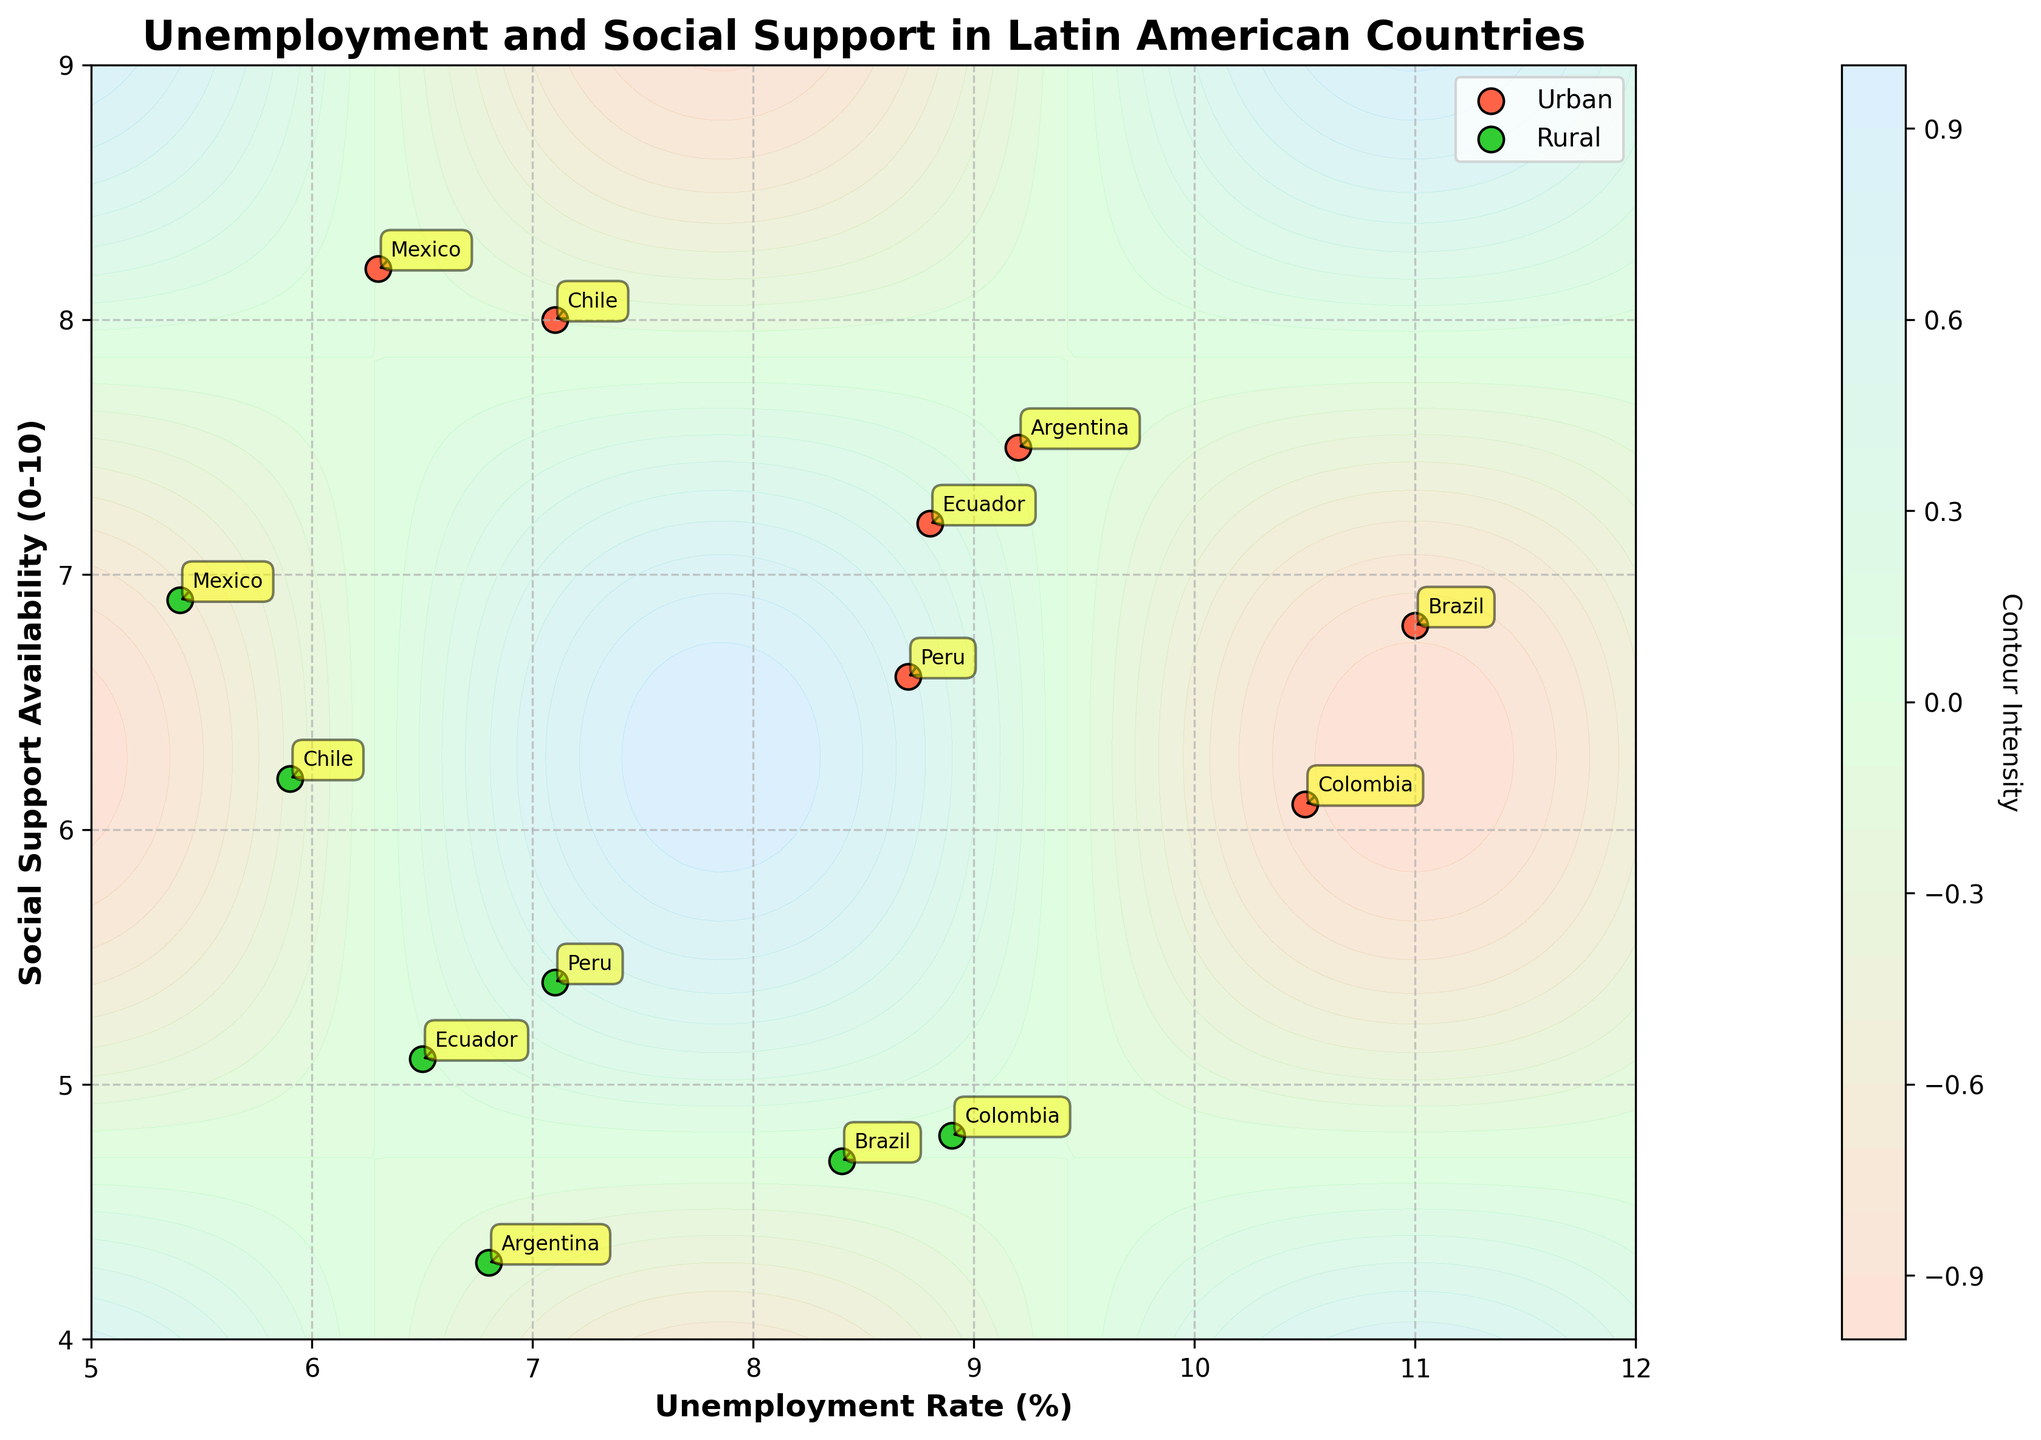What's the title of the figure? The title of the figure is located at the top center of the plot. It reads "Unemployment and Social Support in Latin American Countries".
Answer: Unemployment and Social Support in Latin American Countries What is the unemployment rate for rural areas in Mexico? To find the unemployment rate for rural areas in Mexico, look at the scatter point labeled "Mexico" within the green dots. The unemployment rate is marked on the horizontal axis.
Answer: 5.4% Which country has the highest social support availability in rural areas? Look at the scatter points in green (which represent rural areas). Identify the point with the highest value on the vertical axis marked "Social Support Availability (0-10)". The highest point corresponds to Mexico.
Answer: Mexico What is the difference in unemployment rate between urban and rural areas in Argentina? Identify the points labeled "Argentina" in both the red and green categories. The unemployment rate for urban areas is 9.2%, and for rural areas, it is 6.8%. Subtract the rural rate from the urban rate: 9.2% - 6.8% = 2.4%.
Answer: 2.4% What is the average social support availability for urban areas in Brazil, Argentina, and Chile? To find this, locate the points for urban areas in Brazil, Argentina, and Chile (red scatter points). The social support availabilities are 6.8 for Brazil, 7.5 for Argentina, and 8.0 for Chile. Calculate: (6.8 + 7.5 + 8.0) / 3 = 7.43.
Answer: 7.43 Between Chile and Colombia, which country has a higher unemployment rate in rural areas? Look at the green scatter points labeled "Chile" and "Colombia". The unemployment rate for rural Chile is 5.9%, and for rural Colombia, it is 8.9%. Colombia has a higher rate.
Answer: Colombia How does social support availability vary between urban and rural areas in Ecuador? Locate Ecuador's points in both urban (red) and rural (green). Urban social support is 7.2, while rural is 5.1. The difference is 7.2 - 5.1 = 2.1.
Answer: 2.1 Which area type has more points clustered around higher unemployment rates? Observe the scatter points' distribution. Notice there are more points in the red category (urban) clustered near higher unemployment rates (8% and above).
Answer: Urban What is the combined social support availability for rural areas in Peru and Ecuador? Check the scatter points for rural areas of Peru and Ecuador. Their social support values are 5.4 and 5.1, respectively. Sum them up: 5.4 + 5.1 = 10.5.
Answer: 10.5 What is the color scheme used for the contour plot, and what does it represent? The color scheme transitions from a light color to a darker one, indicating varying intensities of the contour levels. This specific plot uses colors like coral and light green to reflect different intensities of a calculated function (sin(X) * cos(Y)).
Answer: It uses a gradient of colors to represent different contour intensities 